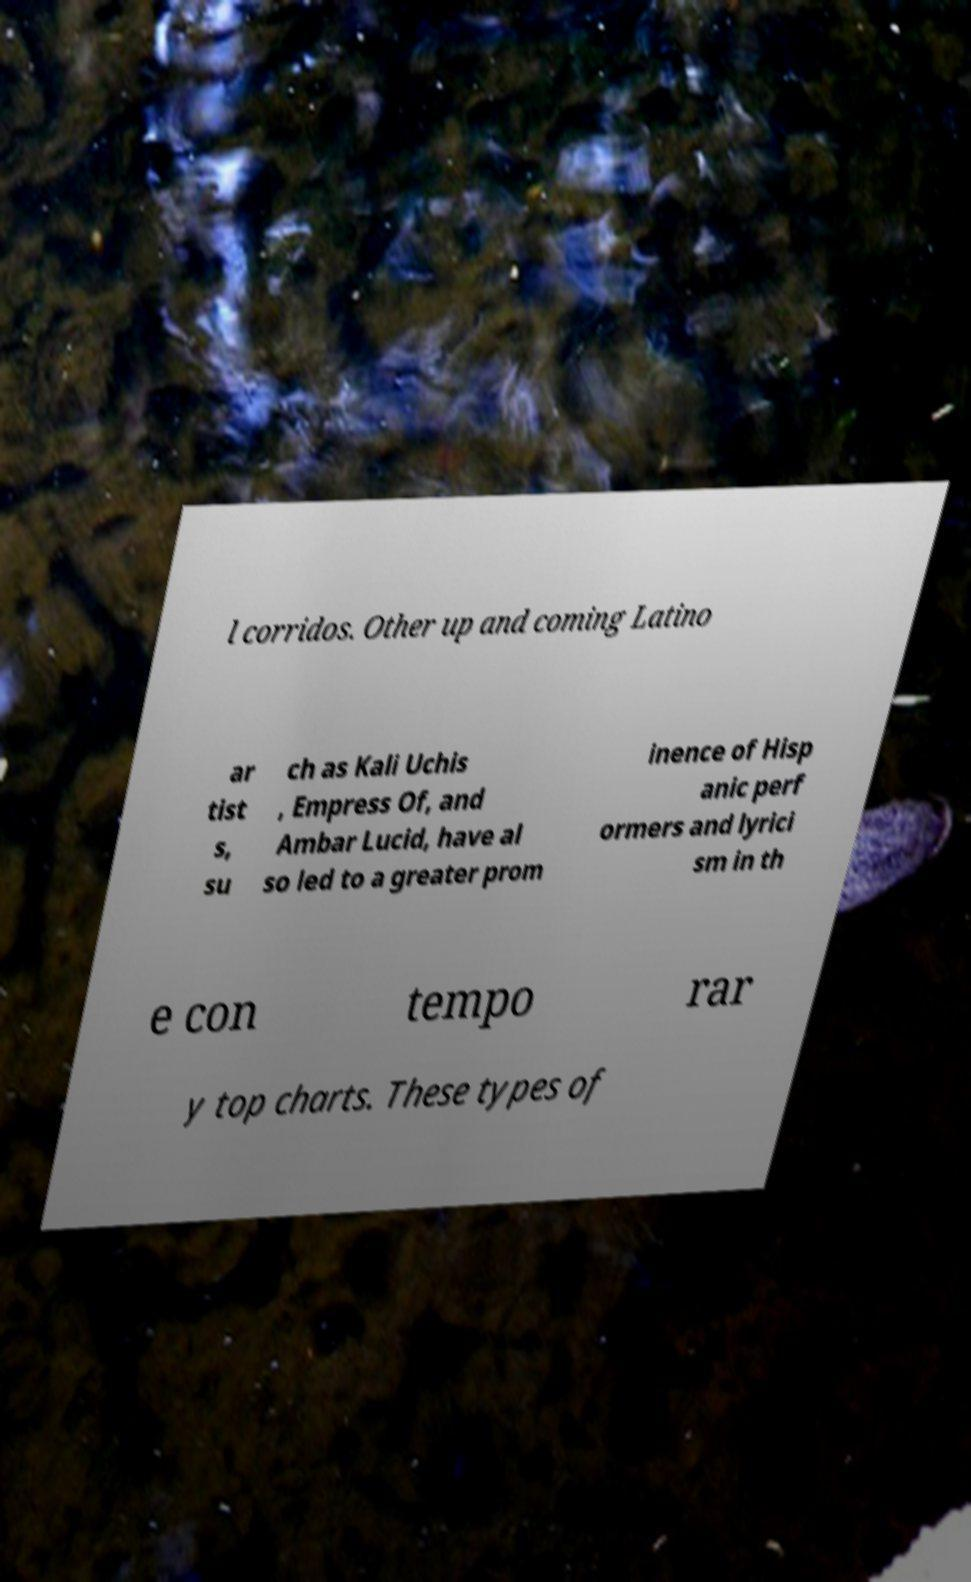Please identify and transcribe the text found in this image. l corridos. Other up and coming Latino ar tist s, su ch as Kali Uchis , Empress Of, and Ambar Lucid, have al so led to a greater prom inence of Hisp anic perf ormers and lyrici sm in th e con tempo rar y top charts. These types of 